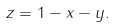Convert formula to latex. <formula><loc_0><loc_0><loc_500><loc_500>z = 1 - x - y .</formula> 